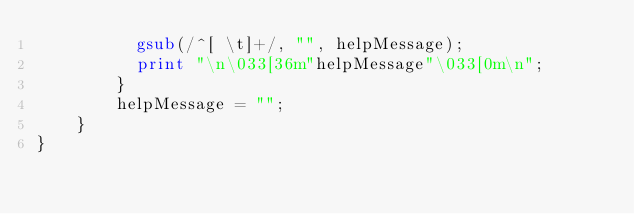<code> <loc_0><loc_0><loc_500><loc_500><_Awk_>          gsub(/^[ \t]+/, "", helpMessage);
          print "\n\033[36m"helpMessage"\033[0m\n";
        }
        helpMessage = "";
    }
}</code> 